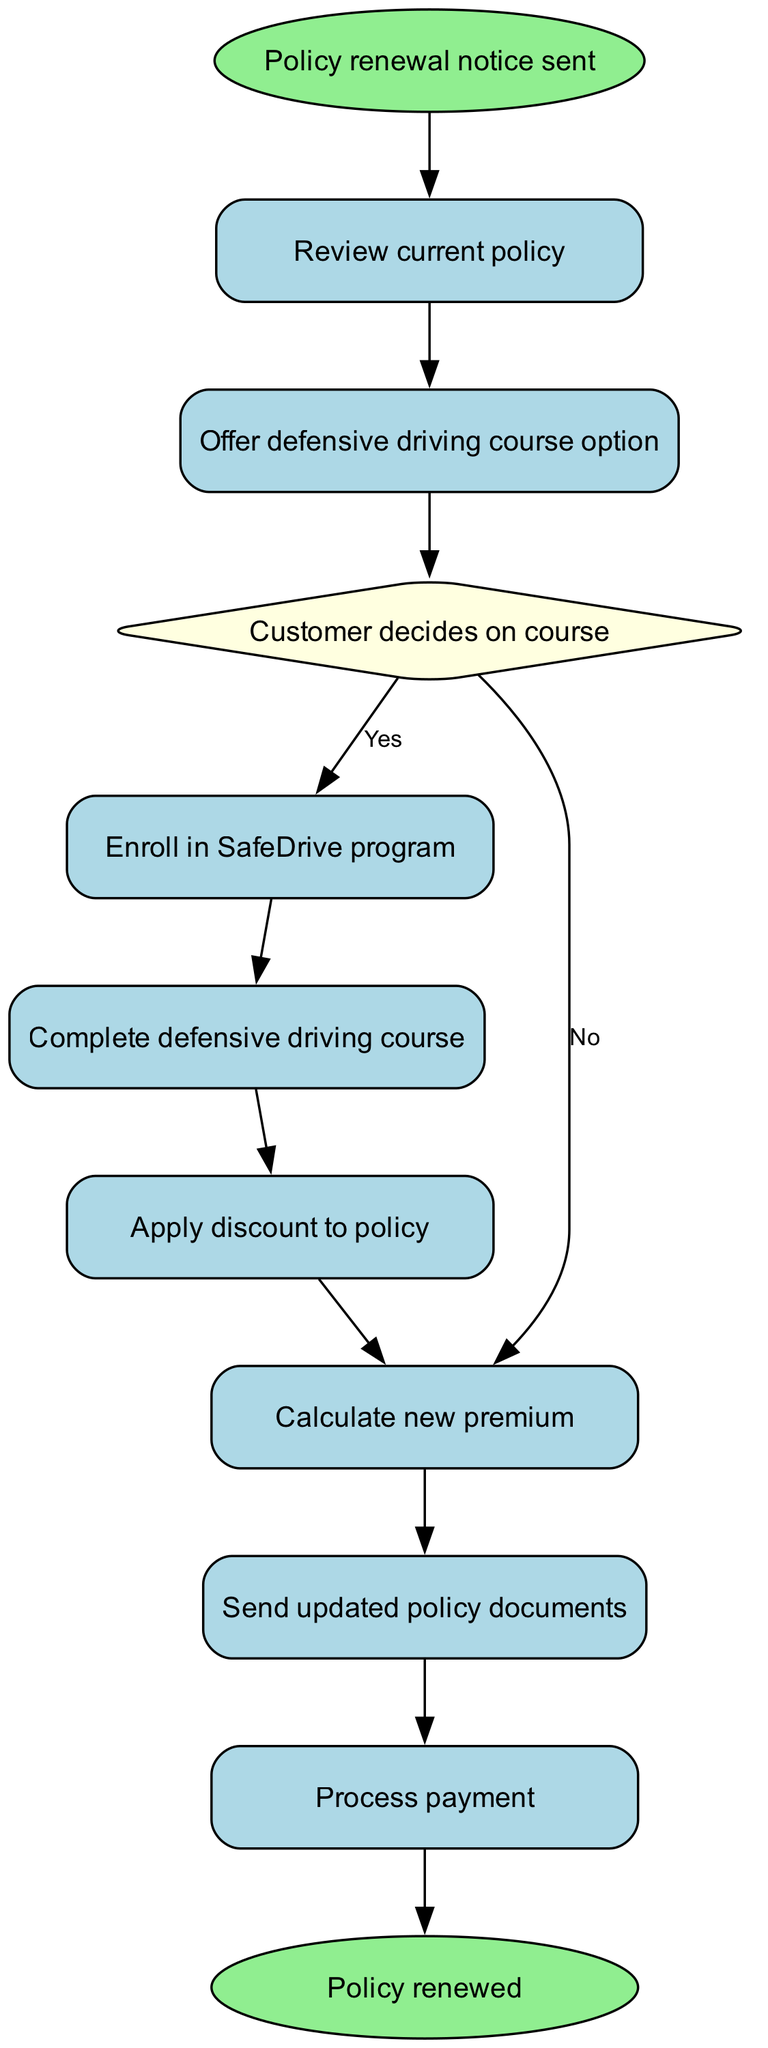What is the starting point of the policy renewal process? The starting point of the process is indicated by the 'start' node labeled 'Policy renewal notice sent.' This is the first step before any actions are taken.
Answer: Policy renewal notice sent How many decision options does the customer have after being offered the defensive driving course? After being offered the defensive driving course, the next node shows that there is a decision point where the customer can either choose 'Yes' or 'No.' Therefore, there are two decision options available.
Answer: 2 What happens if the customer decides not to take the course? If the customer decides not to take the course, the flow chart indicates the path leads directly to calculating the new premium, which is represented in node '7.' This path circumvents the completion of a course and discount application.
Answer: Calculate new premium What is the last action in the policy renewal process? The last action in the process is represented in the end node, labeled 'Policy renewed.' This indicates the conclusion of the process after all required actions have been completed.
Answer: Policy renewed What is the flow from enrolling in the SafeDrive program to processing payment? Upon enrolling in the SafeDrive program (node '4'), the flow proceeds to complete the defensive driving course (node '5'), applying the discount (node '6'), calculating the new premium (node '7'), and then finally processes the payment (node '9'). This sequence follows all steps needed after enrollment to reach payment processing.
Answer: Complete defensive driving course, Apply discount to policy, Calculate new premium, Process payment How many nodes describe actions to be completed by the customer? The flow chart includes four nodes that represent actions to be completed by the customer, specifically nodes '4' (Enroll in SafeDrive program), '5' (Complete defensive driving course), '6' (Apply discount to policy), and '9' (Process payment).
Answer: 4 What is the relationship between the defensive driving course and the discount? The relationship as shown in the diagram is such that completing the defensive driving course (node '5') directly leads to applying the discount to the policy (node '6'). Completing the course is a prerequisite for obtaining the discount.
Answer: Completing the course leads to discount application What follows after the review of the current policy? After reviewing the current policy (node '1'), the flow chart directs the customer to the next step of being offered the defensive driving course option (node '2'), which indicates the sequence of actions to take next.
Answer: Offer defensive driving course option 